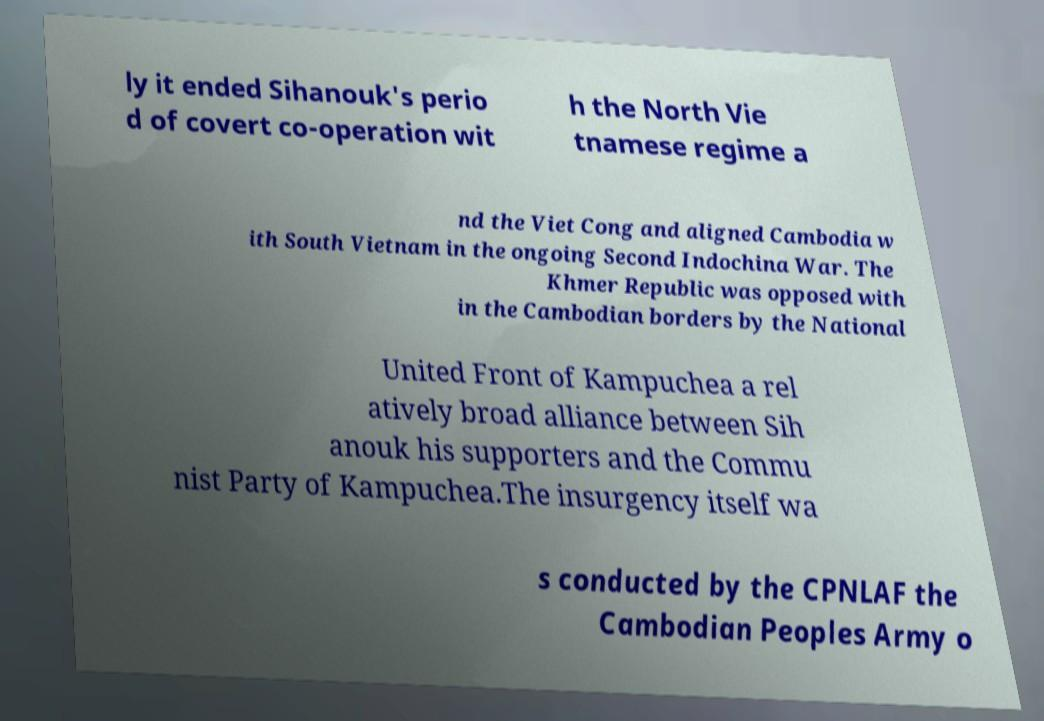Please identify and transcribe the text found in this image. ly it ended Sihanouk's perio d of covert co-operation wit h the North Vie tnamese regime a nd the Viet Cong and aligned Cambodia w ith South Vietnam in the ongoing Second Indochina War. The Khmer Republic was opposed with in the Cambodian borders by the National United Front of Kampuchea a rel atively broad alliance between Sih anouk his supporters and the Commu nist Party of Kampuchea.The insurgency itself wa s conducted by the CPNLAF the Cambodian Peoples Army o 